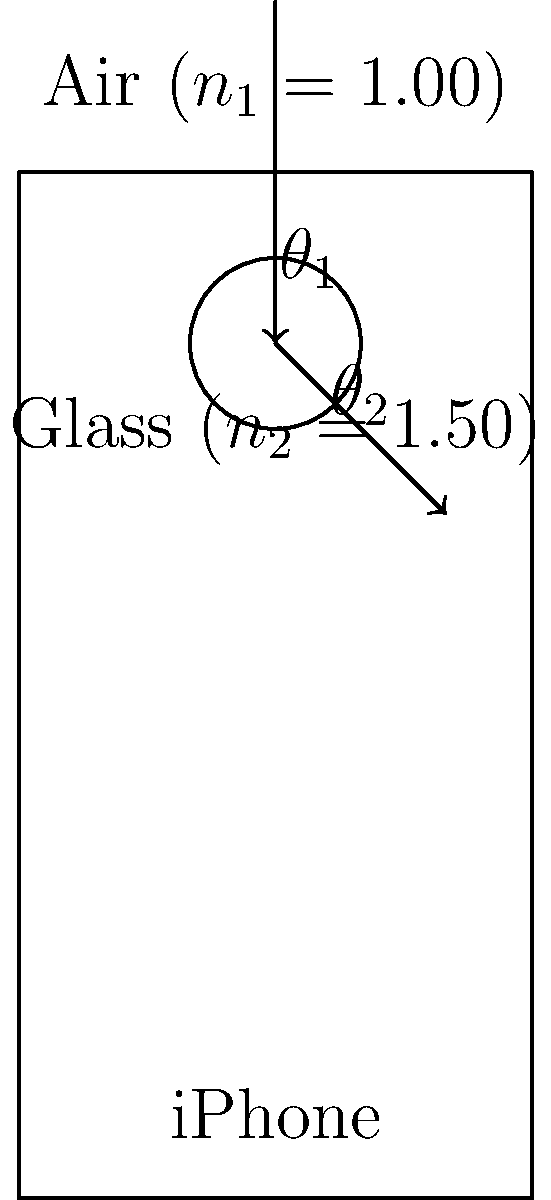As a loyal Apple user, you're curious about the physics behind your iPhone's camera. A light ray enters the camera lens of your iPhone at an angle of $30^\circ$ to the normal. If the lens is made of glass with a refractive index of 1.50, what is the angle of refraction inside the lens? (Assume the air's refractive index is 1.00) To solve this problem, we'll use Snell's Law, which describes the relationship between the angles of incidence and refraction for light passing through different media:

$$n_1 \sin(\theta_1) = n_2 \sin(\theta_2)$$

Where:
$n_1$ = refractive index of air (1.00)
$n_2$ = refractive index of glass (1.50)
$\theta_1$ = angle of incidence ($30^\circ$)
$\theta_2$ = angle of refraction (unknown)

Step 1: Substitute the known values into Snell's Law:
$$(1.00) \sin(30^\circ) = (1.50) \sin(\theta_2)$$

Step 2: Simplify the left side of the equation:
$$0.5 = 1.50 \sin(\theta_2)$$

Step 3: Divide both sides by 1.50:
$$\frac{0.5}{1.50} = \sin(\theta_2)$$

Step 4: Simplify:
$$0.3333 = \sin(\theta_2)$$

Step 5: Take the inverse sine (arcsin) of both sides:
$$\theta_2 = \arcsin(0.3333)$$

Step 6: Calculate the final result:
$$\theta_2 \approx 19.47^\circ$$

Therefore, the angle of refraction inside the iPhone's camera lens is approximately $19.47^\circ$.
Answer: $19.47^\circ$ 